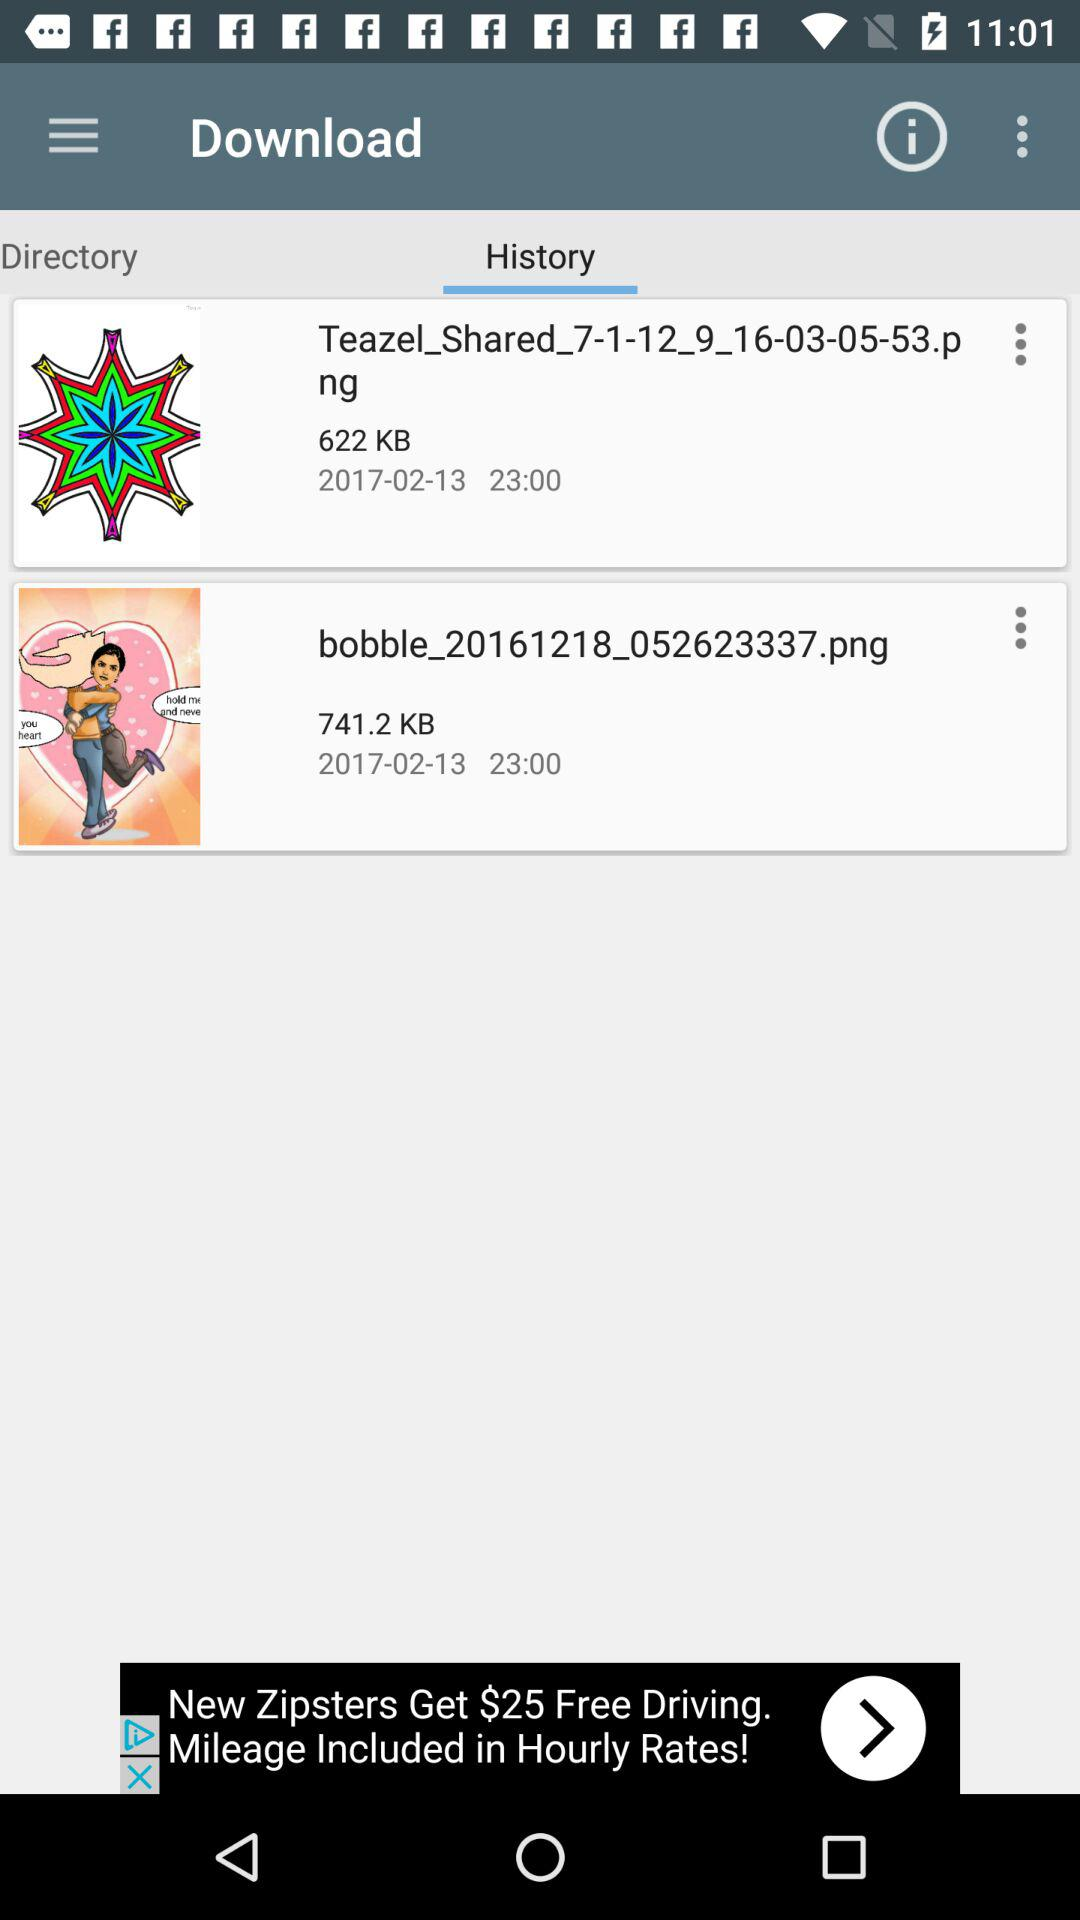How many KBs are the two files combined?
Answer the question using a single word or phrase. 1363.2 